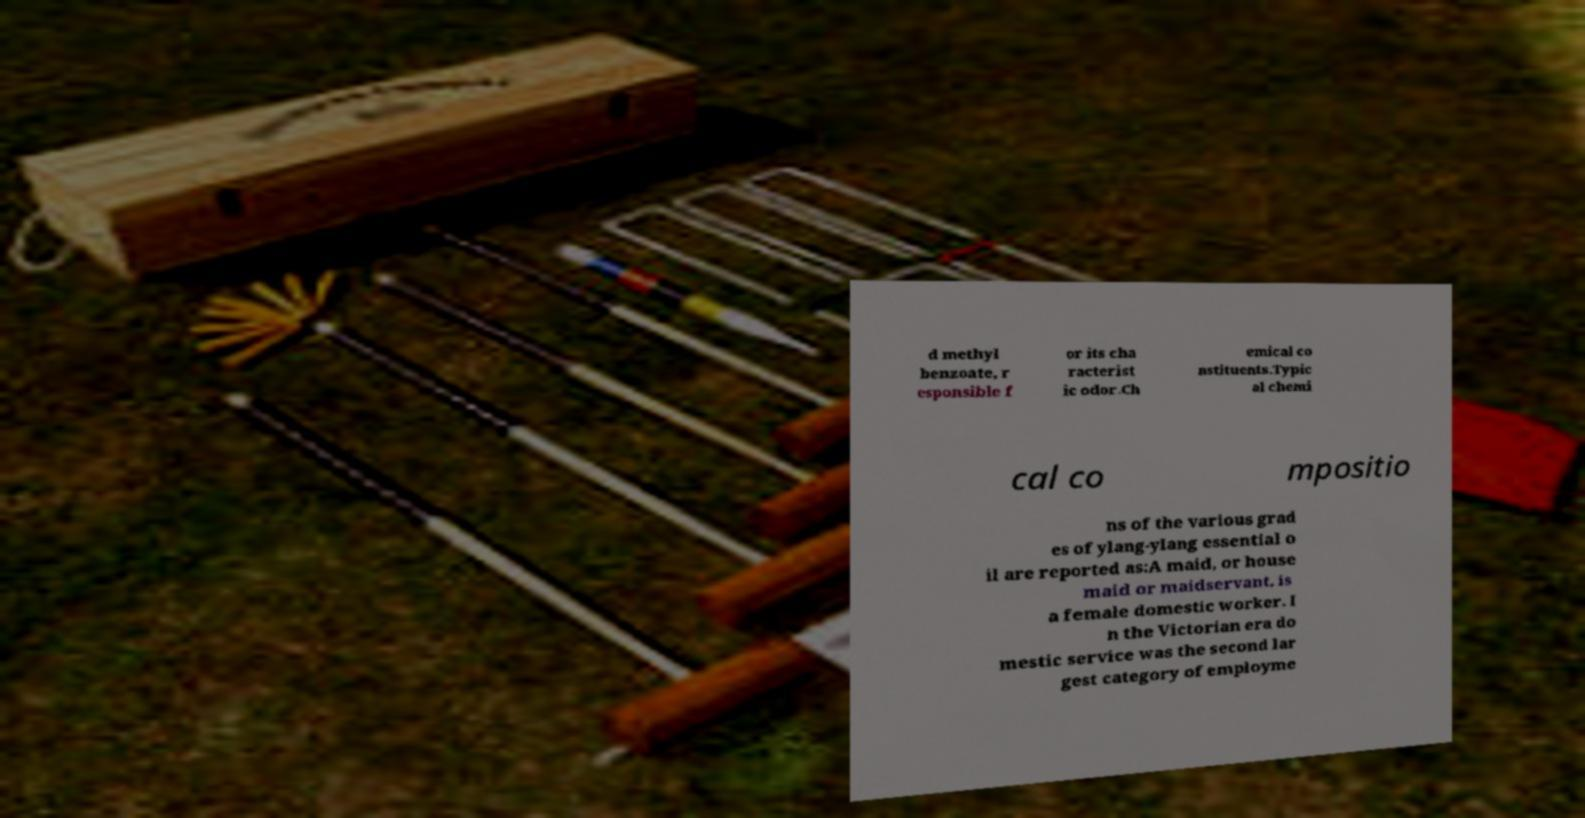Please identify and transcribe the text found in this image. d methyl benzoate, r esponsible f or its cha racterist ic odor.Ch emical co nstituents.Typic al chemi cal co mpositio ns of the various grad es of ylang-ylang essential o il are reported as:A maid, or house maid or maidservant, is a female domestic worker. I n the Victorian era do mestic service was the second lar gest category of employme 